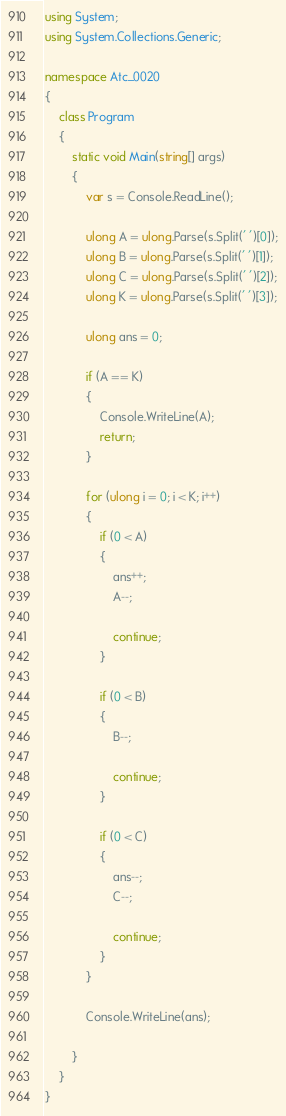<code> <loc_0><loc_0><loc_500><loc_500><_C#_>using System;
using System.Collections.Generic;

namespace Atc_0020
{
    class Program
    {
        static void Main(string[] args)
        {
            var s = Console.ReadLine();

            ulong A = ulong.Parse(s.Split(' ')[0]);
            ulong B = ulong.Parse(s.Split(' ')[1]);
            ulong C = ulong.Parse(s.Split(' ')[2]);
            ulong K = ulong.Parse(s.Split(' ')[3]);

            ulong ans = 0;

            if (A == K)
            {
                Console.WriteLine(A);
                return;
            }

            for (ulong i = 0; i < K; i++)
            {
                if (0 < A)
                {
                    ans++;
                    A--;

                    continue;
                }

                if (0 < B)
                {
                    B--;

                    continue;
                }

                if (0 < C)
                {
                    ans--;
                    C--;

                    continue;
                }
            }

            Console.WriteLine(ans);

        }
    }
}
</code> 